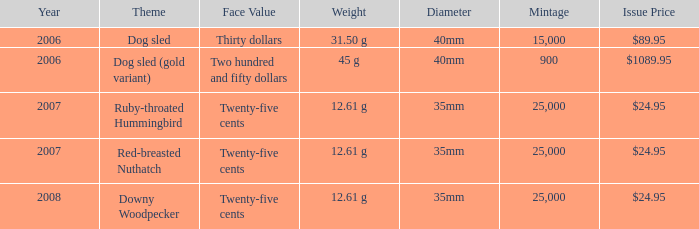What is the Year of the Coin with an Issue Price of $1089.95 and Mintage less than 900? None. 